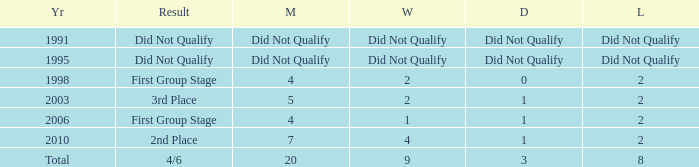What were the matches where the teams finished in the first group stage, in 1998? 4.0. 